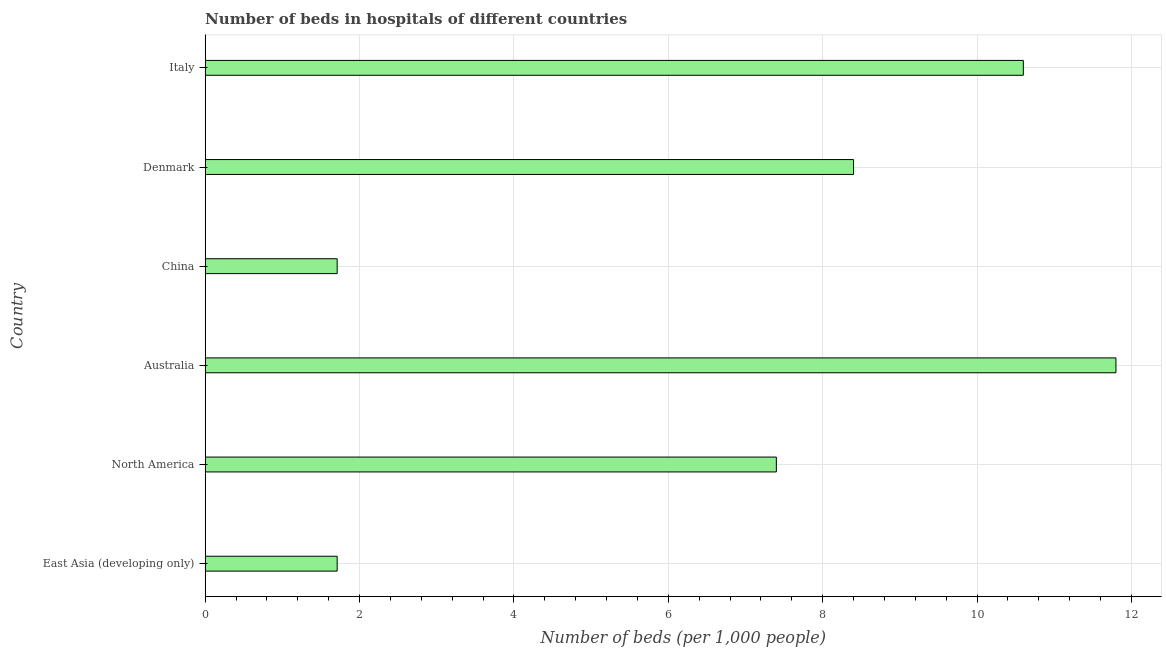Does the graph contain any zero values?
Ensure brevity in your answer.  No. Does the graph contain grids?
Your answer should be compact. Yes. What is the title of the graph?
Offer a very short reply. Number of beds in hospitals of different countries. What is the label or title of the X-axis?
Your response must be concise. Number of beds (per 1,0 people). What is the label or title of the Y-axis?
Make the answer very short. Country. What is the number of hospital beds in North America?
Ensure brevity in your answer.  7.4. Across all countries, what is the maximum number of hospital beds?
Offer a terse response. 11.8. Across all countries, what is the minimum number of hospital beds?
Give a very brief answer. 1.71. In which country was the number of hospital beds minimum?
Your answer should be compact. East Asia (developing only). What is the sum of the number of hospital beds?
Keep it short and to the point. 41.62. What is the difference between the number of hospital beds in China and Denmark?
Provide a short and direct response. -6.69. What is the average number of hospital beds per country?
Your answer should be very brief. 6.94. What is the median number of hospital beds?
Your response must be concise. 7.9. What is the ratio of the number of hospital beds in East Asia (developing only) to that in Italy?
Offer a terse response. 0.16. Is the difference between the number of hospital beds in China and East Asia (developing only) greater than the difference between any two countries?
Keep it short and to the point. No. What is the difference between the highest and the second highest number of hospital beds?
Make the answer very short. 1.2. Is the sum of the number of hospital beds in East Asia (developing only) and North America greater than the maximum number of hospital beds across all countries?
Provide a short and direct response. No. What is the difference between the highest and the lowest number of hospital beds?
Provide a succinct answer. 10.09. In how many countries, is the number of hospital beds greater than the average number of hospital beds taken over all countries?
Provide a succinct answer. 4. Are all the bars in the graph horizontal?
Provide a short and direct response. Yes. What is the difference between two consecutive major ticks on the X-axis?
Give a very brief answer. 2. Are the values on the major ticks of X-axis written in scientific E-notation?
Offer a very short reply. No. What is the Number of beds (per 1,000 people) of East Asia (developing only)?
Your answer should be compact. 1.71. What is the Number of beds (per 1,000 people) of North America?
Offer a terse response. 7.4. What is the Number of beds (per 1,000 people) in Australia?
Offer a terse response. 11.8. What is the Number of beds (per 1,000 people) in China?
Provide a short and direct response. 1.71. What is the Number of beds (per 1,000 people) in Denmark?
Give a very brief answer. 8.4. What is the Number of beds (per 1,000 people) of Italy?
Offer a very short reply. 10.6. What is the difference between the Number of beds (per 1,000 people) in East Asia (developing only) and North America?
Your answer should be compact. -5.69. What is the difference between the Number of beds (per 1,000 people) in East Asia (developing only) and Australia?
Provide a short and direct response. -10.09. What is the difference between the Number of beds (per 1,000 people) in East Asia (developing only) and China?
Make the answer very short. 0. What is the difference between the Number of beds (per 1,000 people) in East Asia (developing only) and Denmark?
Keep it short and to the point. -6.69. What is the difference between the Number of beds (per 1,000 people) in East Asia (developing only) and Italy?
Offer a terse response. -8.89. What is the difference between the Number of beds (per 1,000 people) in North America and Australia?
Offer a very short reply. -4.4. What is the difference between the Number of beds (per 1,000 people) in North America and China?
Your answer should be compact. 5.69. What is the difference between the Number of beds (per 1,000 people) in North America and Denmark?
Provide a short and direct response. -1. What is the difference between the Number of beds (per 1,000 people) in North America and Italy?
Offer a very short reply. -3.2. What is the difference between the Number of beds (per 1,000 people) in Australia and China?
Give a very brief answer. 10.09. What is the difference between the Number of beds (per 1,000 people) in Australia and Denmark?
Provide a short and direct response. 3.4. What is the difference between the Number of beds (per 1,000 people) in Australia and Italy?
Provide a short and direct response. 1.2. What is the difference between the Number of beds (per 1,000 people) in China and Denmark?
Ensure brevity in your answer.  -6.69. What is the difference between the Number of beds (per 1,000 people) in China and Italy?
Provide a short and direct response. -8.89. What is the ratio of the Number of beds (per 1,000 people) in East Asia (developing only) to that in North America?
Make the answer very short. 0.23. What is the ratio of the Number of beds (per 1,000 people) in East Asia (developing only) to that in Australia?
Keep it short and to the point. 0.14. What is the ratio of the Number of beds (per 1,000 people) in East Asia (developing only) to that in Denmark?
Ensure brevity in your answer.  0.2. What is the ratio of the Number of beds (per 1,000 people) in East Asia (developing only) to that in Italy?
Make the answer very short. 0.16. What is the ratio of the Number of beds (per 1,000 people) in North America to that in Australia?
Offer a very short reply. 0.63. What is the ratio of the Number of beds (per 1,000 people) in North America to that in China?
Provide a short and direct response. 4.33. What is the ratio of the Number of beds (per 1,000 people) in North America to that in Denmark?
Offer a very short reply. 0.88. What is the ratio of the Number of beds (per 1,000 people) in North America to that in Italy?
Offer a terse response. 0.7. What is the ratio of the Number of beds (per 1,000 people) in Australia to that in China?
Provide a short and direct response. 6.9. What is the ratio of the Number of beds (per 1,000 people) in Australia to that in Denmark?
Provide a short and direct response. 1.41. What is the ratio of the Number of beds (per 1,000 people) in Australia to that in Italy?
Offer a terse response. 1.11. What is the ratio of the Number of beds (per 1,000 people) in China to that in Denmark?
Give a very brief answer. 0.2. What is the ratio of the Number of beds (per 1,000 people) in China to that in Italy?
Your answer should be very brief. 0.16. What is the ratio of the Number of beds (per 1,000 people) in Denmark to that in Italy?
Your answer should be compact. 0.79. 